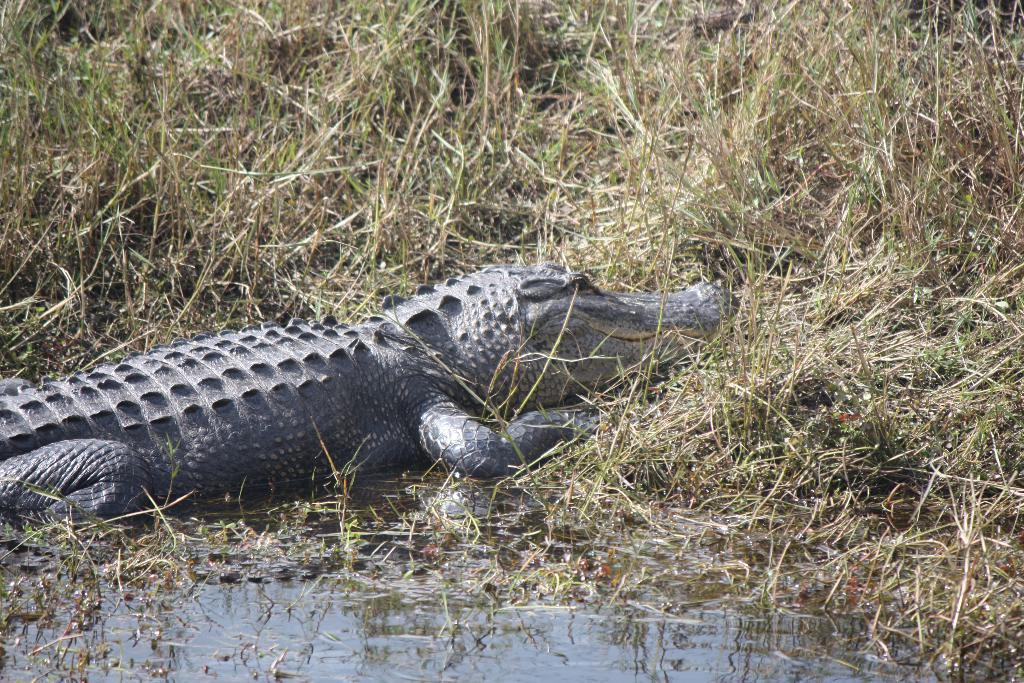What animal is in the water in the image? There is a crocodile in the water in the image. What can be seen in the background of the image? There are plants visible in the background of the image. What type of grain is being harvested by the crocodile in the image? There is no grain present in the image, as it features a crocodile in the water and plants in the background. 